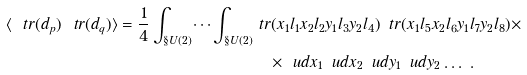Convert formula to latex. <formula><loc_0><loc_0><loc_500><loc_500>\langle \ t r ( d _ { p } ) \ t r ( d _ { q } ) \rangle = \frac { 1 } { 4 } \int _ { \S U ( 2 ) } \dots \int _ { \S U ( 2 ) } & \ t r ( x _ { 1 } l _ { 1 } x _ { 2 } l _ { 2 } y _ { 1 } l _ { 3 } y _ { 2 } l _ { 4 } ) \, \ t r ( x _ { 1 } l _ { 5 } x _ { 2 } l _ { 6 } y _ { 1 } l _ { 7 } y _ { 2 } l _ { 8 } ) \times \\ & \quad \times \ u d x _ { 1 } \, \ u d x _ { 2 } \, \ u d y _ { 1 } \, \ u d y _ { 2 } \dots \ .</formula> 